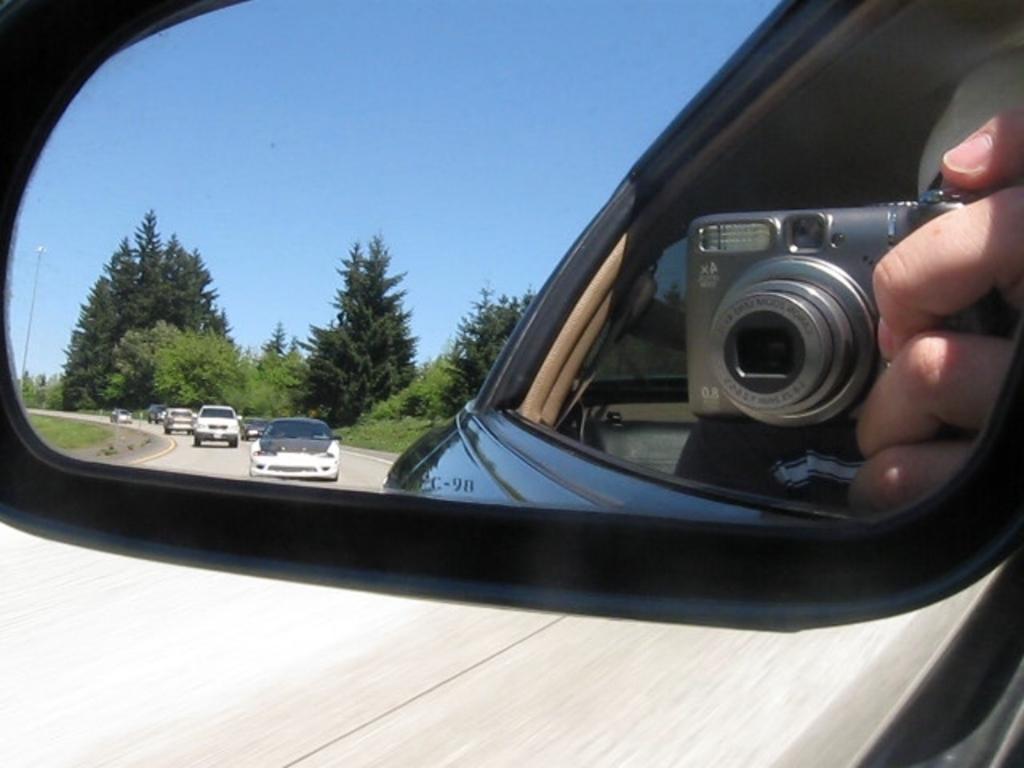Describe this image in one or two sentences. In this image, we can see a vehicle and there is a mirror, through the glass we can see a person holding a camera and there are trees and some vehicles on the road and there is a pole. 